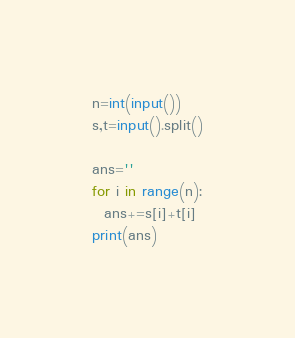<code> <loc_0><loc_0><loc_500><loc_500><_Python_>n=int(input())
s,t=input().split()

ans=''
for i in range(n):
  ans+=s[i]+t[i]
print(ans)</code> 